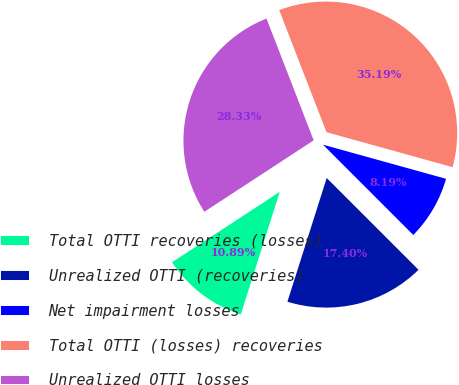<chart> <loc_0><loc_0><loc_500><loc_500><pie_chart><fcel>Total OTTI recoveries (losses)<fcel>Unrealized OTTI (recoveries)<fcel>Net impairment losses<fcel>Total OTTI (losses) recoveries<fcel>Unrealized OTTI losses<nl><fcel>10.89%<fcel>17.4%<fcel>8.19%<fcel>35.19%<fcel>28.33%<nl></chart> 